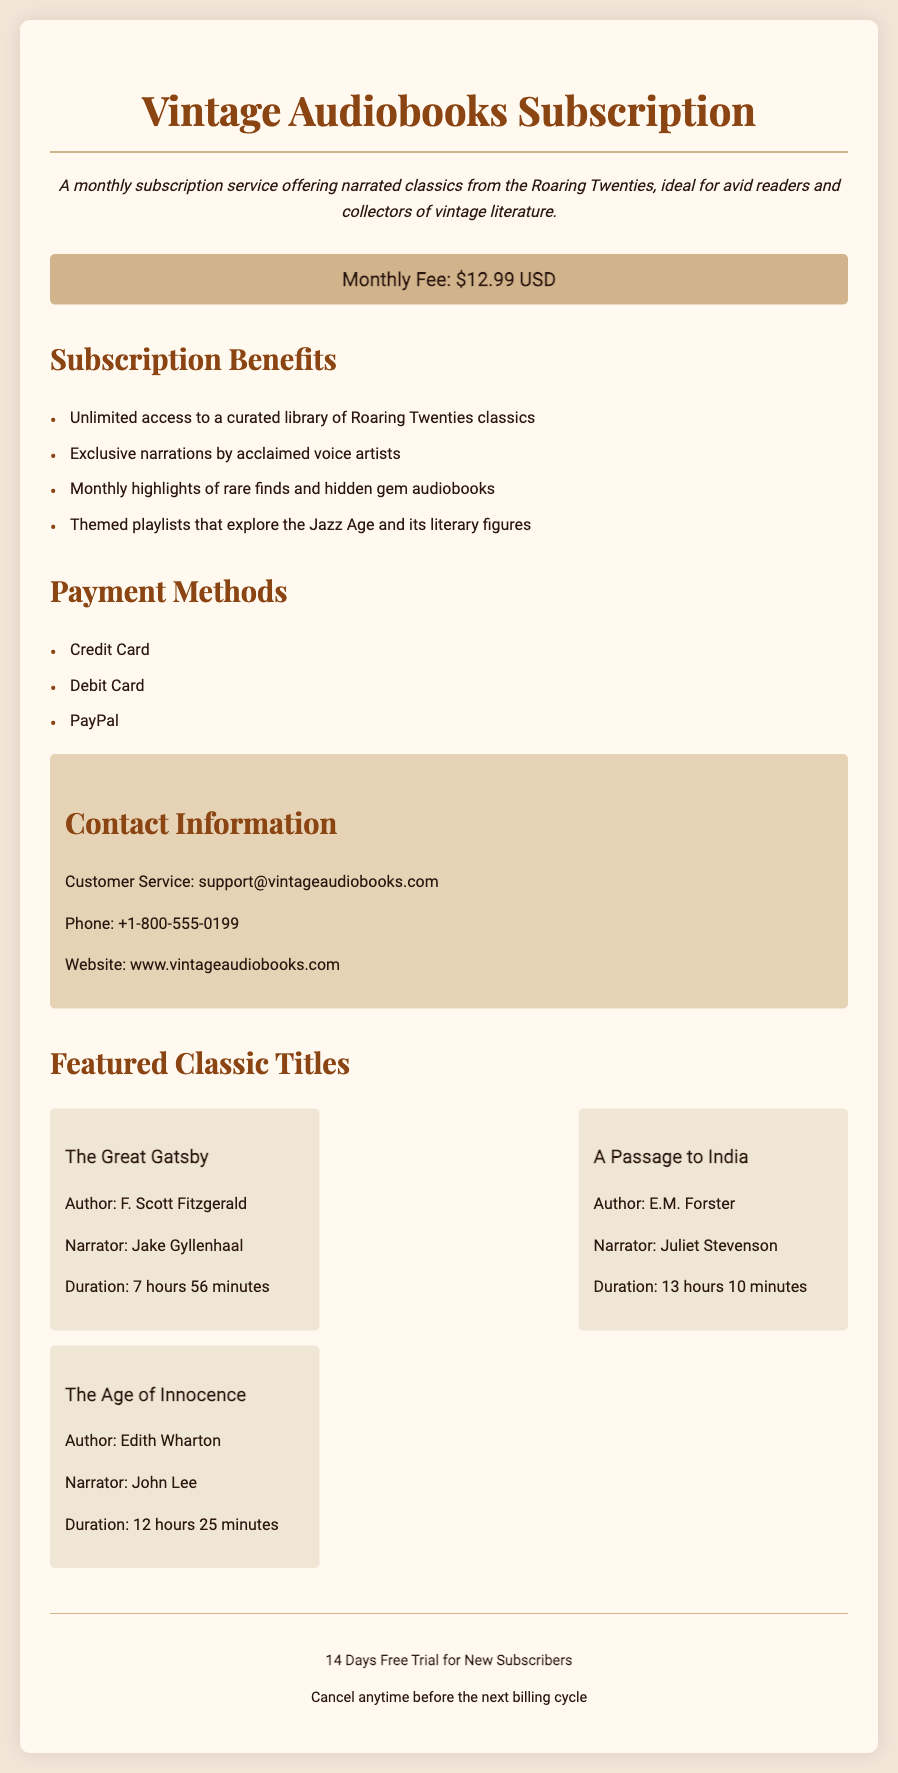What is the monthly fee? The monthly fee listed in the document is $12.99 USD.
Answer: $12.99 USD What is the contact email for customer service? The document provides the email address for customer service as support@vintageaudiobooks.com.
Answer: support@vintageaudiobooks.com Who authored "The Great Gatsby"? The author of "The Great Gatsby" mentioned in the document is F. Scott Fitzgerald.
Answer: F. Scott Fitzgerald How long is the narration of "A Passage to India"? The document states that the duration of the narration for "A Passage to India" is 13 hours 10 minutes.
Answer: 13 hours 10 minutes What payment methods are accepted? The document lists Credit Card, Debit Card, and PayPal as acceptable payment methods.
Answer: Credit Card, Debit Card, PayPal What kind of titles does the subscription offer? The subscription offers curated classics from the Roaring Twenties.
Answer: Curated classics from the Roaring Twenties What is the duration of the free trial for new subscribers? According to the document, the free trial duration for new subscribers is 14 days.
Answer: 14 Days Can subscribers cancel anytime? The document confirms that subscribers can cancel anytime before the next billing cycle.
Answer: Yes 